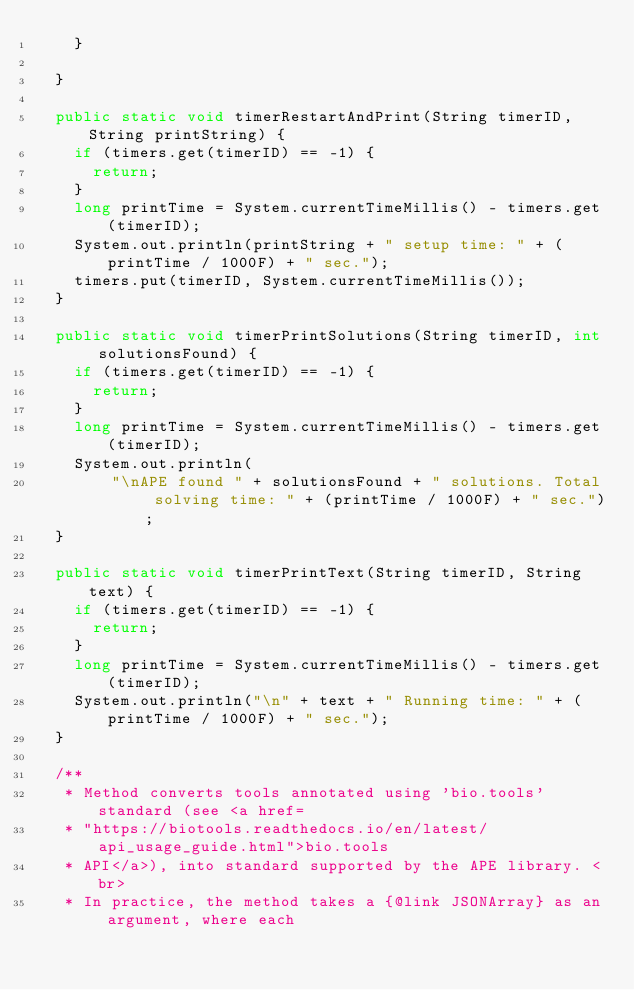<code> <loc_0><loc_0><loc_500><loc_500><_Java_>		}

	}

	public static void timerRestartAndPrint(String timerID, String printString) {
		if (timers.get(timerID) == -1) {
			return;
		}
		long printTime = System.currentTimeMillis() - timers.get(timerID);
		System.out.println(printString + " setup time: " + (printTime / 1000F) + " sec.");
		timers.put(timerID, System.currentTimeMillis());
	}

	public static void timerPrintSolutions(String timerID, int solutionsFound) {
		if (timers.get(timerID) == -1) {
			return;
		}
		long printTime = System.currentTimeMillis() - timers.get(timerID);
		System.out.println(
				"\nAPE found " + solutionsFound + " solutions. Total solving time: " + (printTime / 1000F) + " sec.");
	}

	public static void timerPrintText(String timerID, String text) {
		if (timers.get(timerID) == -1) {
			return;
		}
		long printTime = System.currentTimeMillis() - timers.get(timerID);
		System.out.println("\n" + text + " Running time: " + (printTime / 1000F) + " sec.");
	}

	/**
	 * Method converts tools annotated using 'bio.tools' standard (see <a href=
	 * "https://biotools.readthedocs.io/en/latest/api_usage_guide.html">bio.tools
	 * API</a>), into standard supported by the APE library. <br>
	 * In practice, the method takes a {@link JSONArray} as an argument, where each</code> 